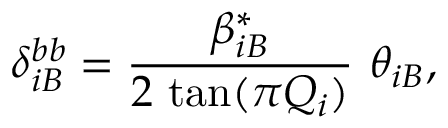<formula> <loc_0><loc_0><loc_500><loc_500>\delta _ { i B } ^ { b b } = \frac { \beta _ { i B } ^ { * } } { 2 \, \tan ( \pi Q _ { i } ) } \theta _ { i B } ,</formula> 